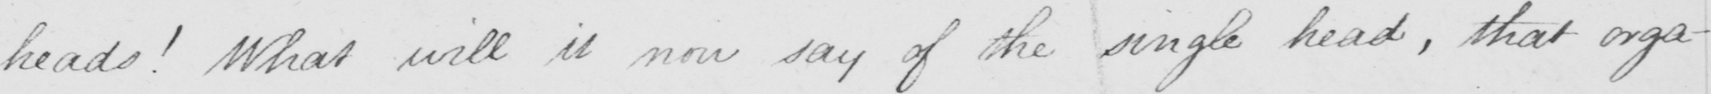What text is written in this handwritten line? heads !  What will it now say of the single head , that orga- 